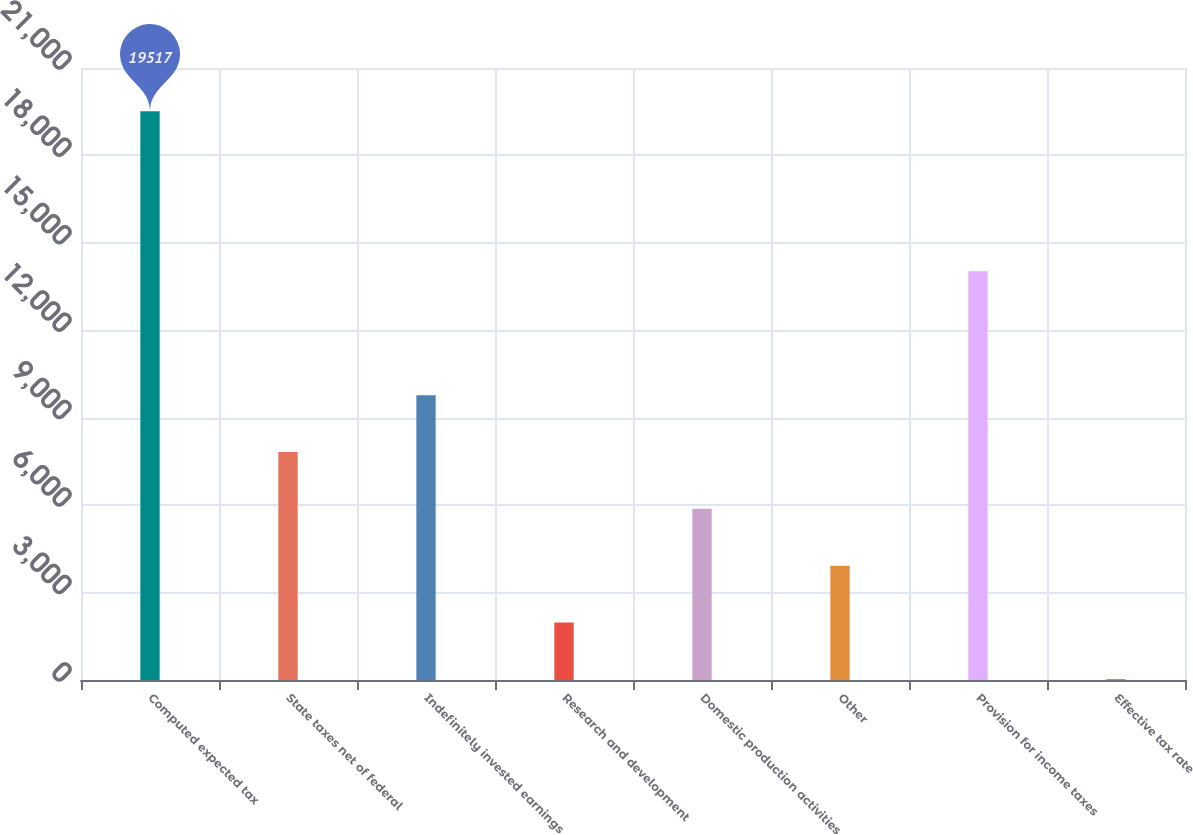<chart> <loc_0><loc_0><loc_500><loc_500><bar_chart><fcel>Computed expected tax<fcel>State taxes net of federal<fcel>Indefinitely invested earnings<fcel>Research and development<fcel>Domestic production activities<fcel>Other<fcel>Provision for income taxes<fcel>Effective tax rate<nl><fcel>19517<fcel>7821.92<fcel>9771.1<fcel>1974.38<fcel>5872.74<fcel>3923.56<fcel>14030<fcel>25.2<nl></chart> 